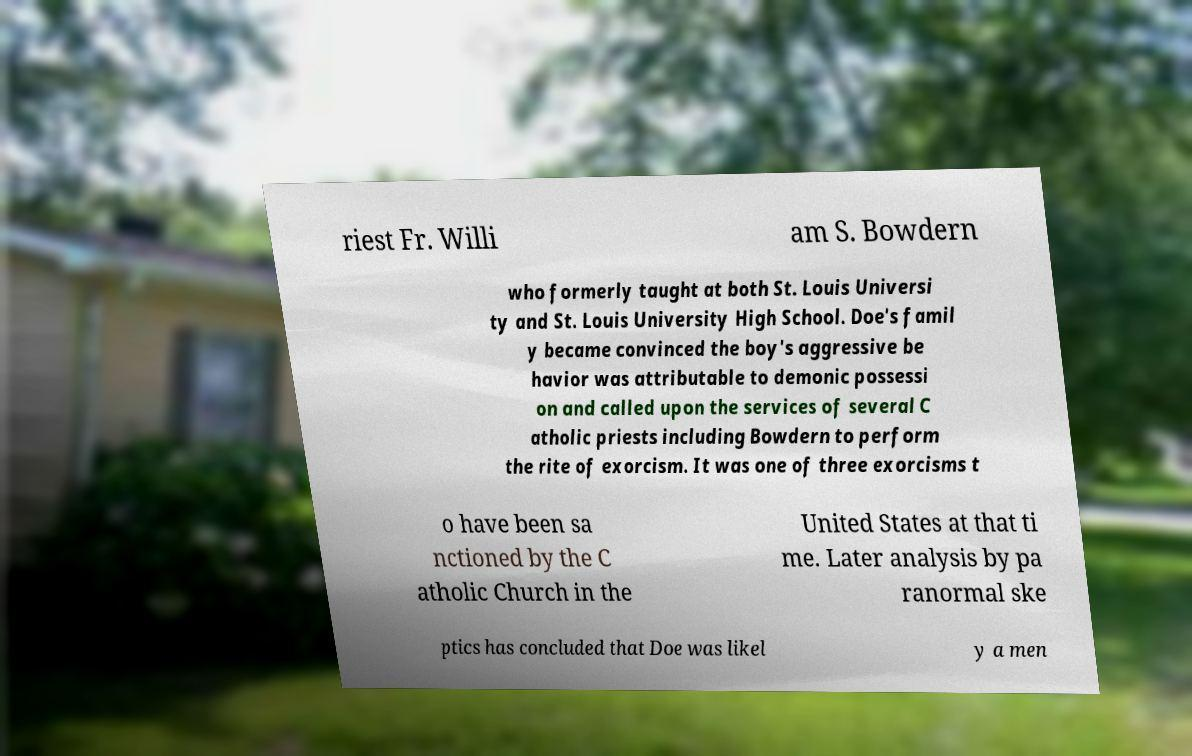Please identify and transcribe the text found in this image. riest Fr. Willi am S. Bowdern who formerly taught at both St. Louis Universi ty and St. Louis University High School. Doe's famil y became convinced the boy's aggressive be havior was attributable to demonic possessi on and called upon the services of several C atholic priests including Bowdern to perform the rite of exorcism. It was one of three exorcisms t o have been sa nctioned by the C atholic Church in the United States at that ti me. Later analysis by pa ranormal ske ptics has concluded that Doe was likel y a men 